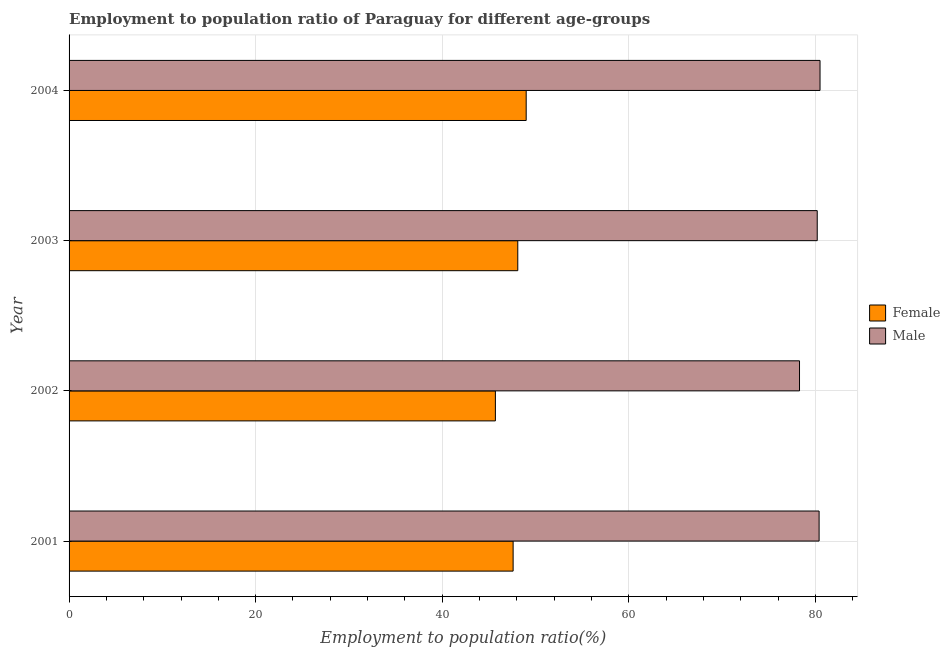Are the number of bars per tick equal to the number of legend labels?
Your answer should be very brief. Yes. How many bars are there on the 4th tick from the top?
Your answer should be very brief. 2. What is the employment to population ratio(female) in 2003?
Your response must be concise. 48.1. Across all years, what is the maximum employment to population ratio(male)?
Your response must be concise. 80.5. Across all years, what is the minimum employment to population ratio(male)?
Provide a succinct answer. 78.3. In which year was the employment to population ratio(female) minimum?
Your answer should be very brief. 2002. What is the total employment to population ratio(male) in the graph?
Give a very brief answer. 319.4. What is the difference between the employment to population ratio(female) in 2002 and the employment to population ratio(male) in 2003?
Provide a succinct answer. -34.5. What is the average employment to population ratio(male) per year?
Ensure brevity in your answer.  79.85. In the year 2001, what is the difference between the employment to population ratio(female) and employment to population ratio(male)?
Offer a very short reply. -32.8. In how many years, is the employment to population ratio(female) greater than 72 %?
Your response must be concise. 0. What is the ratio of the employment to population ratio(female) in 2003 to that in 2004?
Offer a very short reply. 0.98. Is the employment to population ratio(male) in 2003 less than that in 2004?
Provide a short and direct response. Yes. What is the difference between the highest and the lowest employment to population ratio(male)?
Your response must be concise. 2.2. Is the sum of the employment to population ratio(male) in 2001 and 2003 greater than the maximum employment to population ratio(female) across all years?
Your answer should be very brief. Yes. What does the 2nd bar from the bottom in 2004 represents?
Offer a very short reply. Male. Are all the bars in the graph horizontal?
Offer a terse response. Yes. How many years are there in the graph?
Provide a short and direct response. 4. What is the difference between two consecutive major ticks on the X-axis?
Your answer should be compact. 20. Are the values on the major ticks of X-axis written in scientific E-notation?
Give a very brief answer. No. Does the graph contain any zero values?
Offer a terse response. No. How are the legend labels stacked?
Offer a terse response. Vertical. What is the title of the graph?
Your response must be concise. Employment to population ratio of Paraguay for different age-groups. Does "GDP" appear as one of the legend labels in the graph?
Make the answer very short. No. What is the label or title of the X-axis?
Your response must be concise. Employment to population ratio(%). What is the Employment to population ratio(%) of Female in 2001?
Provide a short and direct response. 47.6. What is the Employment to population ratio(%) in Male in 2001?
Offer a terse response. 80.4. What is the Employment to population ratio(%) in Female in 2002?
Your answer should be compact. 45.7. What is the Employment to population ratio(%) of Male in 2002?
Ensure brevity in your answer.  78.3. What is the Employment to population ratio(%) of Female in 2003?
Keep it short and to the point. 48.1. What is the Employment to population ratio(%) in Male in 2003?
Give a very brief answer. 80.2. What is the Employment to population ratio(%) of Female in 2004?
Make the answer very short. 49. What is the Employment to population ratio(%) in Male in 2004?
Provide a succinct answer. 80.5. Across all years, what is the maximum Employment to population ratio(%) of Male?
Provide a succinct answer. 80.5. Across all years, what is the minimum Employment to population ratio(%) in Female?
Your response must be concise. 45.7. Across all years, what is the minimum Employment to population ratio(%) in Male?
Ensure brevity in your answer.  78.3. What is the total Employment to population ratio(%) of Female in the graph?
Offer a very short reply. 190.4. What is the total Employment to population ratio(%) of Male in the graph?
Keep it short and to the point. 319.4. What is the difference between the Employment to population ratio(%) of Male in 2001 and that in 2002?
Offer a very short reply. 2.1. What is the difference between the Employment to population ratio(%) of Female in 2001 and that in 2003?
Offer a very short reply. -0.5. What is the difference between the Employment to population ratio(%) in Female in 2001 and that in 2004?
Keep it short and to the point. -1.4. What is the difference between the Employment to population ratio(%) of Female in 2002 and that in 2003?
Make the answer very short. -2.4. What is the difference between the Employment to population ratio(%) of Male in 2002 and that in 2004?
Offer a very short reply. -2.2. What is the difference between the Employment to population ratio(%) in Female in 2003 and that in 2004?
Provide a short and direct response. -0.9. What is the difference between the Employment to population ratio(%) in Female in 2001 and the Employment to population ratio(%) in Male in 2002?
Keep it short and to the point. -30.7. What is the difference between the Employment to population ratio(%) in Female in 2001 and the Employment to population ratio(%) in Male in 2003?
Your response must be concise. -32.6. What is the difference between the Employment to population ratio(%) in Female in 2001 and the Employment to population ratio(%) in Male in 2004?
Offer a very short reply. -32.9. What is the difference between the Employment to population ratio(%) in Female in 2002 and the Employment to population ratio(%) in Male in 2003?
Ensure brevity in your answer.  -34.5. What is the difference between the Employment to population ratio(%) of Female in 2002 and the Employment to population ratio(%) of Male in 2004?
Your answer should be compact. -34.8. What is the difference between the Employment to population ratio(%) in Female in 2003 and the Employment to population ratio(%) in Male in 2004?
Your answer should be compact. -32.4. What is the average Employment to population ratio(%) in Female per year?
Your answer should be very brief. 47.6. What is the average Employment to population ratio(%) of Male per year?
Give a very brief answer. 79.85. In the year 2001, what is the difference between the Employment to population ratio(%) in Female and Employment to population ratio(%) in Male?
Your answer should be compact. -32.8. In the year 2002, what is the difference between the Employment to population ratio(%) of Female and Employment to population ratio(%) of Male?
Your response must be concise. -32.6. In the year 2003, what is the difference between the Employment to population ratio(%) in Female and Employment to population ratio(%) in Male?
Provide a short and direct response. -32.1. In the year 2004, what is the difference between the Employment to population ratio(%) in Female and Employment to population ratio(%) in Male?
Provide a succinct answer. -31.5. What is the ratio of the Employment to population ratio(%) in Female in 2001 to that in 2002?
Your response must be concise. 1.04. What is the ratio of the Employment to population ratio(%) of Male in 2001 to that in 2002?
Your answer should be very brief. 1.03. What is the ratio of the Employment to population ratio(%) in Male in 2001 to that in 2003?
Ensure brevity in your answer.  1. What is the ratio of the Employment to population ratio(%) in Female in 2001 to that in 2004?
Your answer should be very brief. 0.97. What is the ratio of the Employment to population ratio(%) in Male in 2001 to that in 2004?
Offer a terse response. 1. What is the ratio of the Employment to population ratio(%) of Female in 2002 to that in 2003?
Keep it short and to the point. 0.95. What is the ratio of the Employment to population ratio(%) in Male in 2002 to that in 2003?
Provide a succinct answer. 0.98. What is the ratio of the Employment to population ratio(%) in Female in 2002 to that in 2004?
Offer a very short reply. 0.93. What is the ratio of the Employment to population ratio(%) of Male in 2002 to that in 2004?
Provide a succinct answer. 0.97. What is the ratio of the Employment to population ratio(%) in Female in 2003 to that in 2004?
Ensure brevity in your answer.  0.98. What is the ratio of the Employment to population ratio(%) in Male in 2003 to that in 2004?
Your answer should be very brief. 1. What is the difference between the highest and the second highest Employment to population ratio(%) in Female?
Provide a succinct answer. 0.9. What is the difference between the highest and the lowest Employment to population ratio(%) in Male?
Offer a terse response. 2.2. 